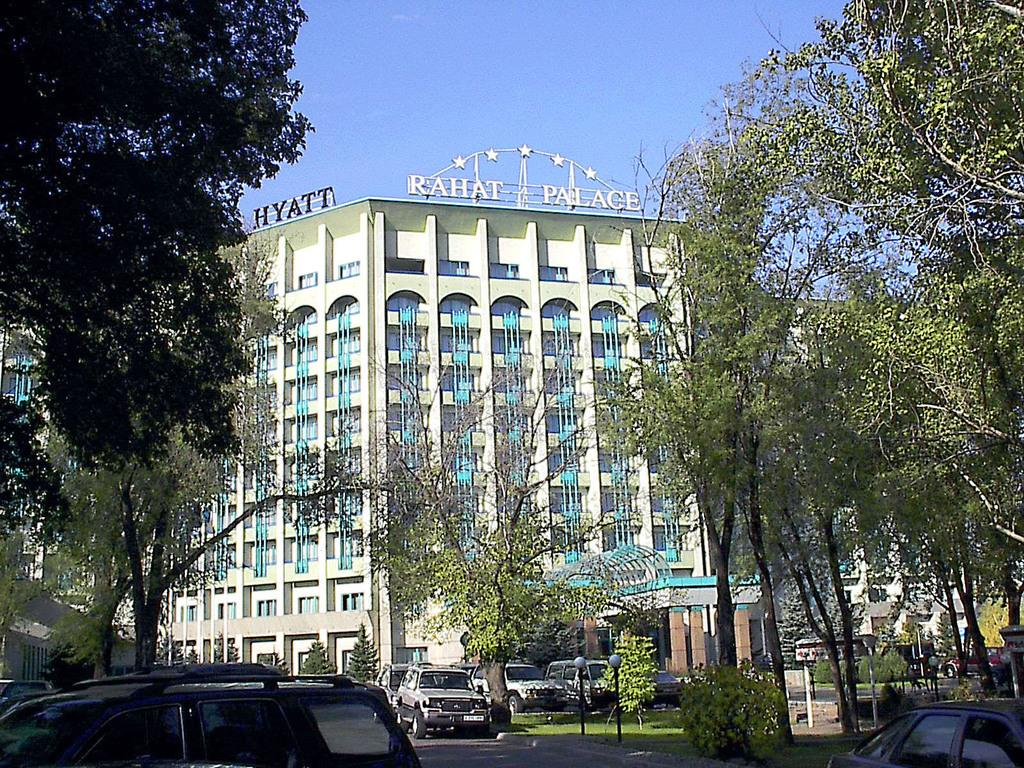What type of vehicles can be seen on the road in the image? There are cars on the road in the image. What structures are present to provide illumination at night? There are street lights in the image. What type of vegetation is visible in the image? There are plants and trees in the image. What type of structures can be seen in the background of the image? There are buildings in the background of the image. What part of the natural environment is visible in the image? The sky is visible in the background of the image. What type of zephyr can be seen blowing through the trees in the image? There is no mention of a zephyr or any wind in the image; it only shows cars, street lights, plants, trees, buildings, and the sky. Where is the vacation destination featured in the image? There is no indication of a vacation destination in the image; it simply shows a scene with cars, street lights, plants, trees, buildings, and the sky. 